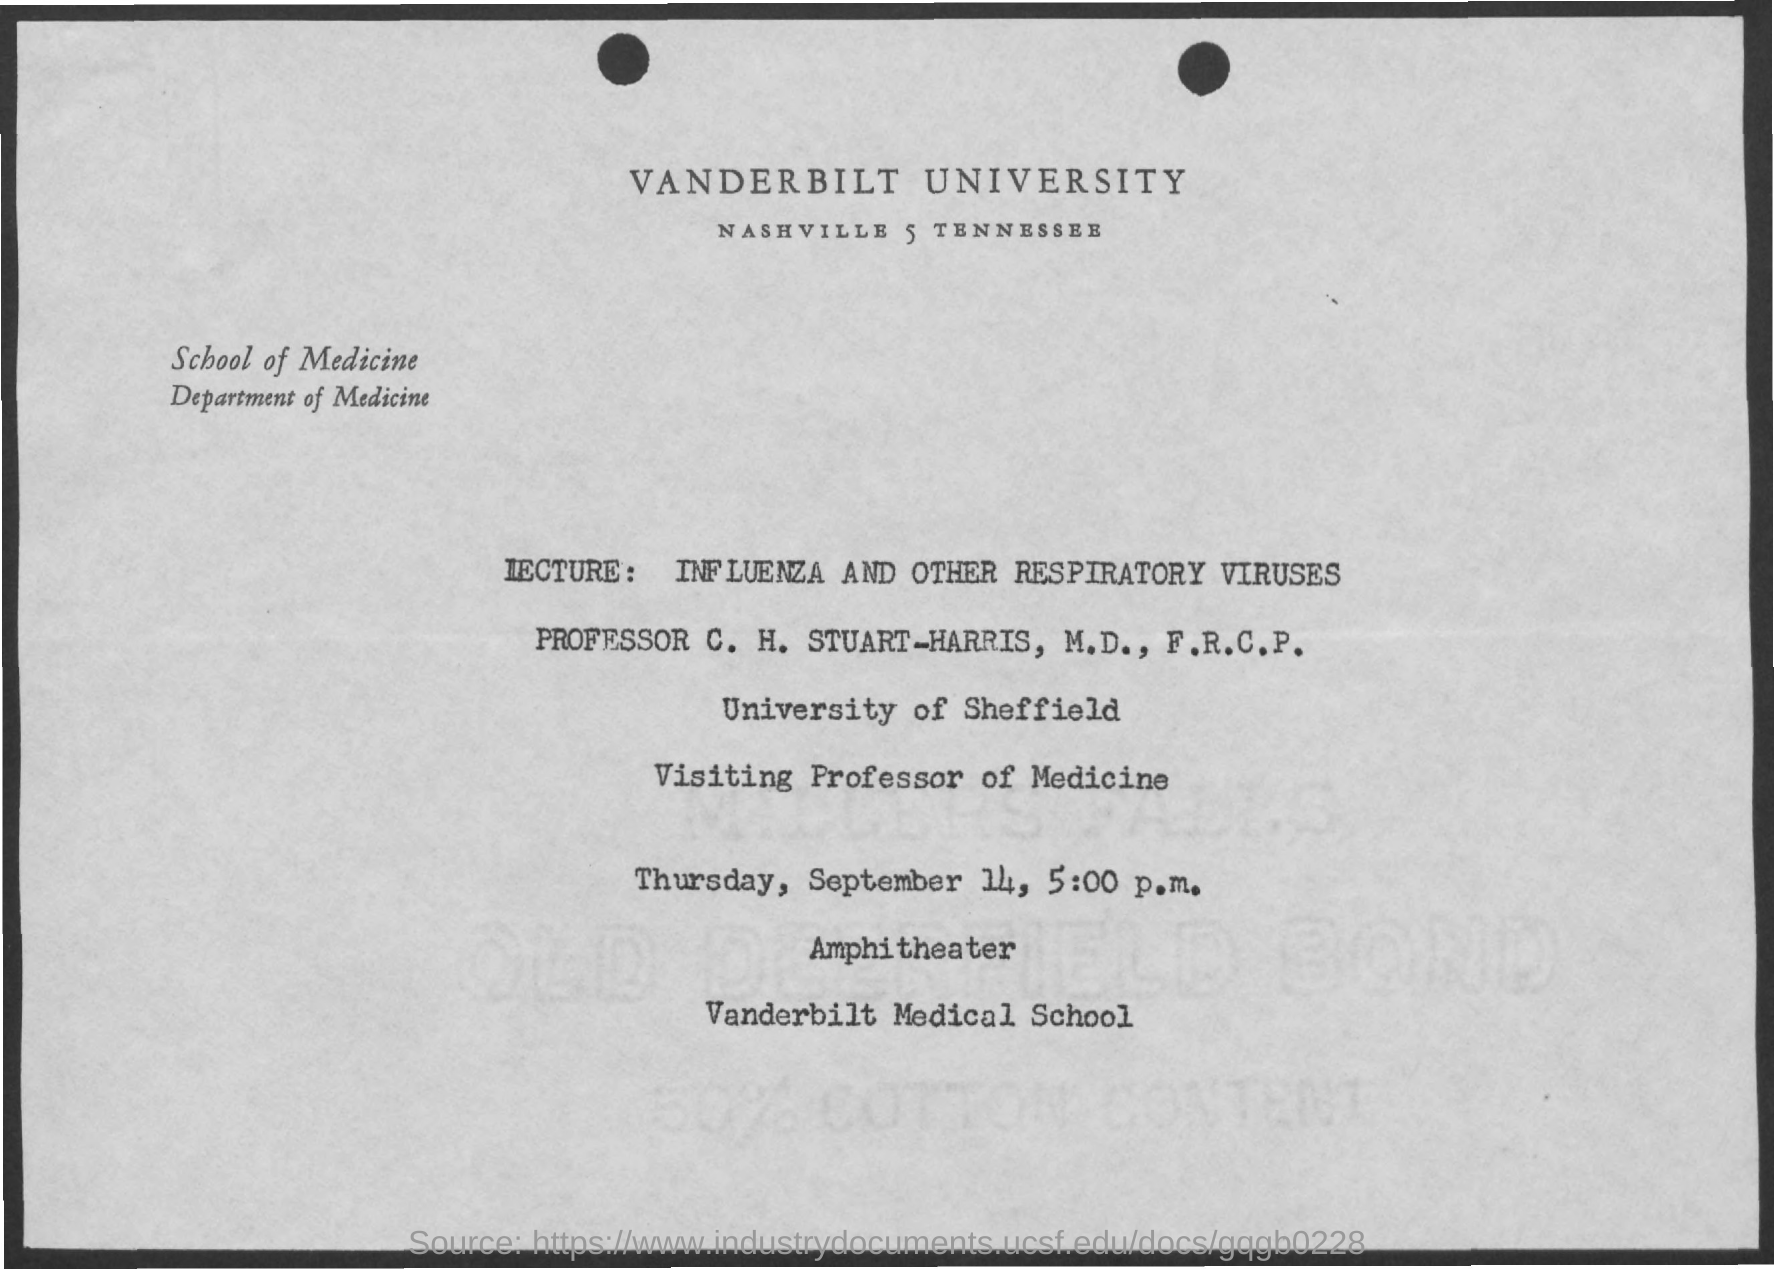Mention a couple of crucial points in this snapshot. The department mentioned in the given form is the Department of Medicine. The lecture discussed influenza and other respiratory viruses. The date mentioned in the given page is September 14th. The time mentioned is 5:00 p.m. 